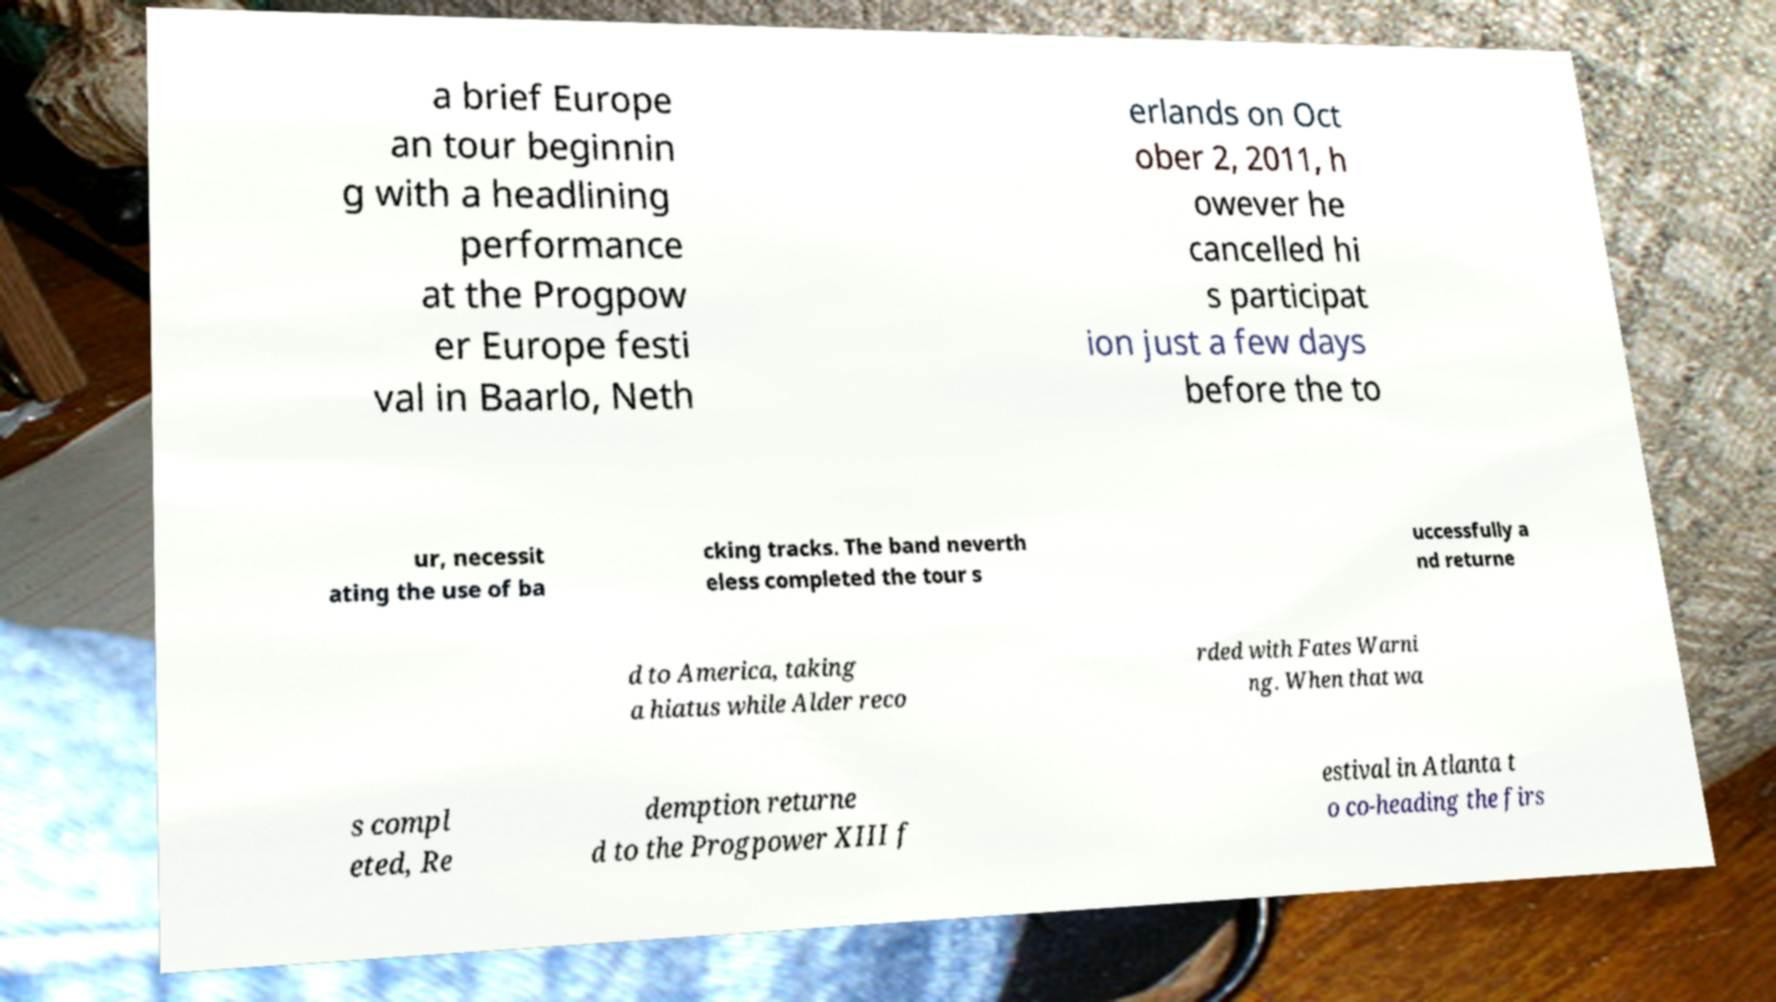Please identify and transcribe the text found in this image. a brief Europe an tour beginnin g with a headlining performance at the Progpow er Europe festi val in Baarlo, Neth erlands on Oct ober 2, 2011, h owever he cancelled hi s participat ion just a few days before the to ur, necessit ating the use of ba cking tracks. The band neverth eless completed the tour s uccessfully a nd returne d to America, taking a hiatus while Alder reco rded with Fates Warni ng. When that wa s compl eted, Re demption returne d to the Progpower XIII f estival in Atlanta t o co-heading the firs 